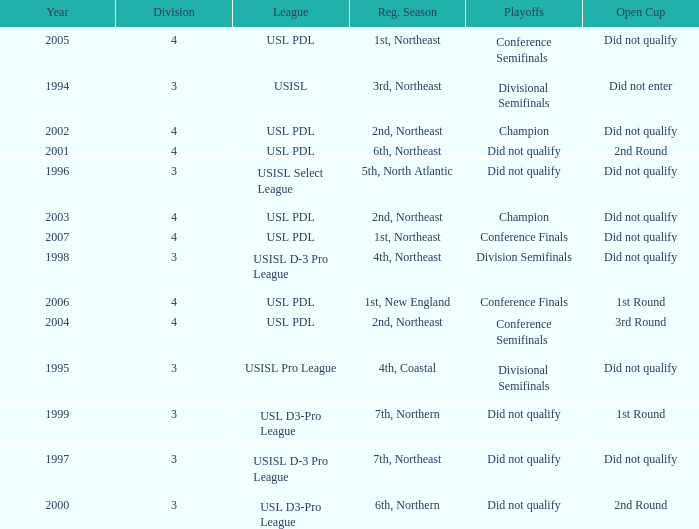Name the playoffs for  usisl select league Did not qualify. 